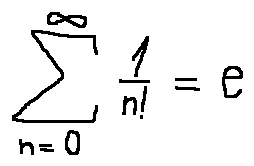<formula> <loc_0><loc_0><loc_500><loc_500>\sum \lim i t s _ { n = 0 } ^ { \infty } \frac { 1 } { n ! } = e</formula> 